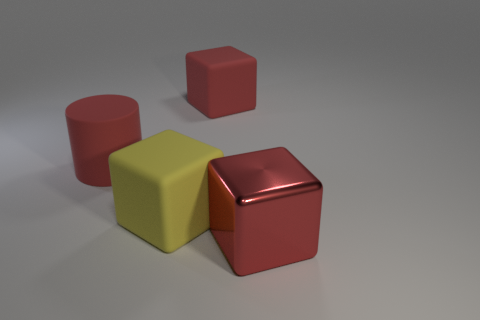Subtract 1 blocks. How many blocks are left? 2 Add 2 cylinders. How many objects exist? 6 Subtract all blocks. How many objects are left? 1 Subtract all red cubes. Subtract all rubber blocks. How many objects are left? 0 Add 1 metal objects. How many metal objects are left? 2 Add 3 big things. How many big things exist? 7 Subtract 0 green cylinders. How many objects are left? 4 